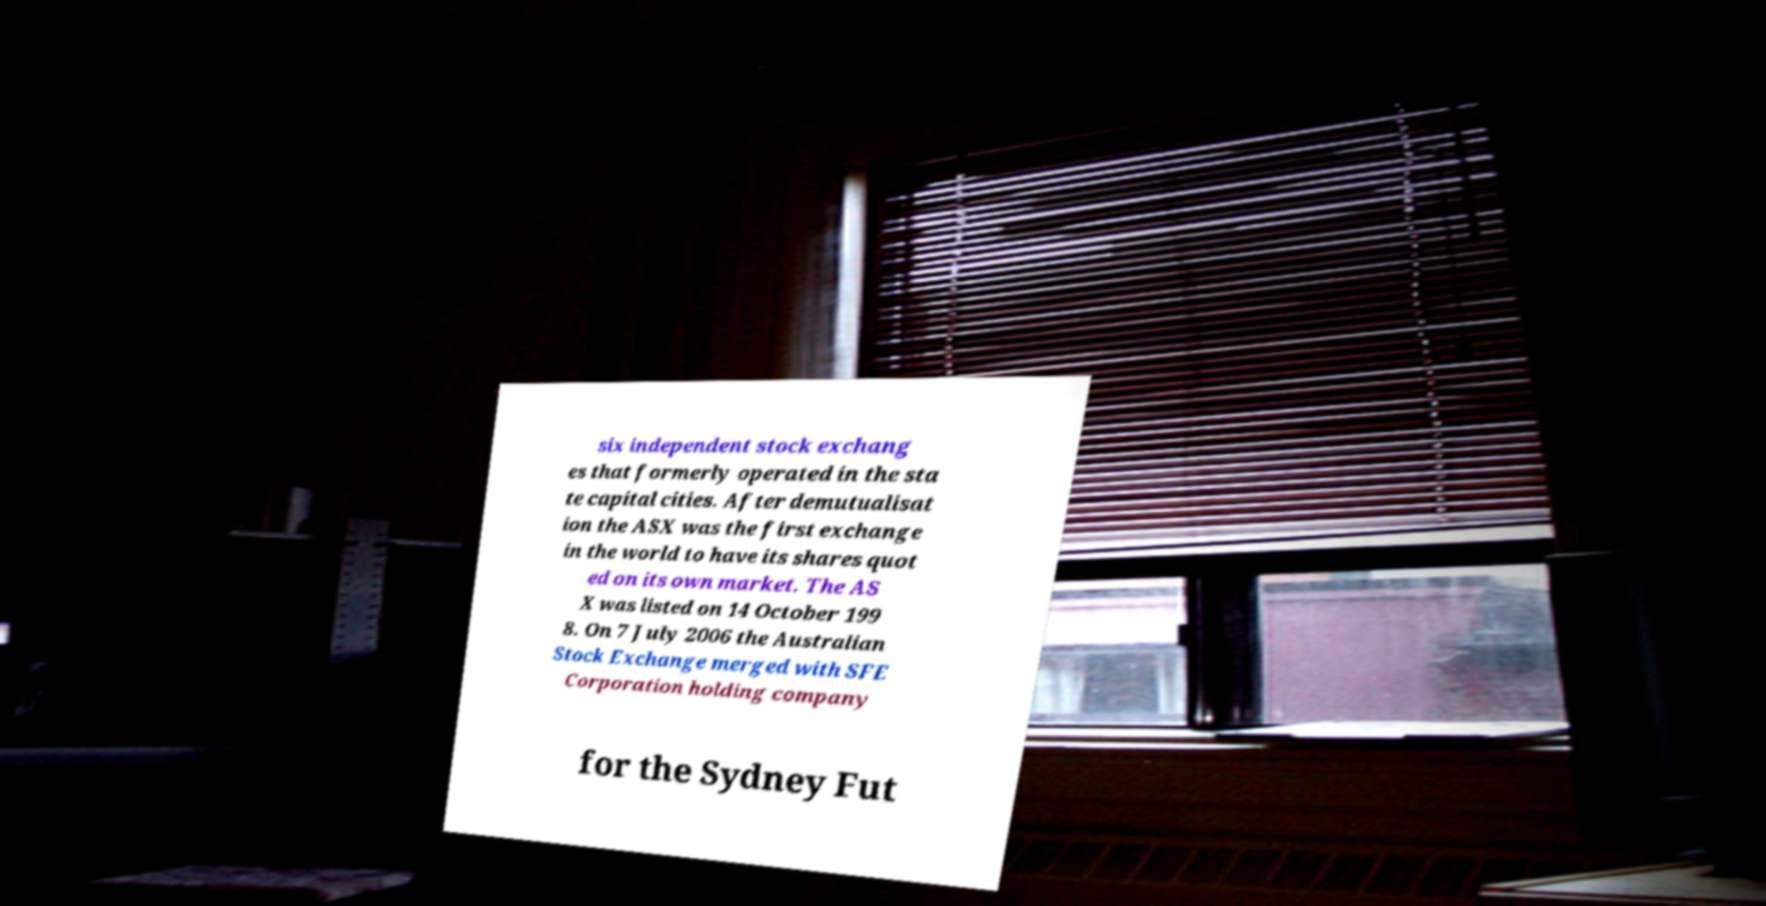I need the written content from this picture converted into text. Can you do that? six independent stock exchang es that formerly operated in the sta te capital cities. After demutualisat ion the ASX was the first exchange in the world to have its shares quot ed on its own market. The AS X was listed on 14 October 199 8. On 7 July 2006 the Australian Stock Exchange merged with SFE Corporation holding company for the Sydney Fut 